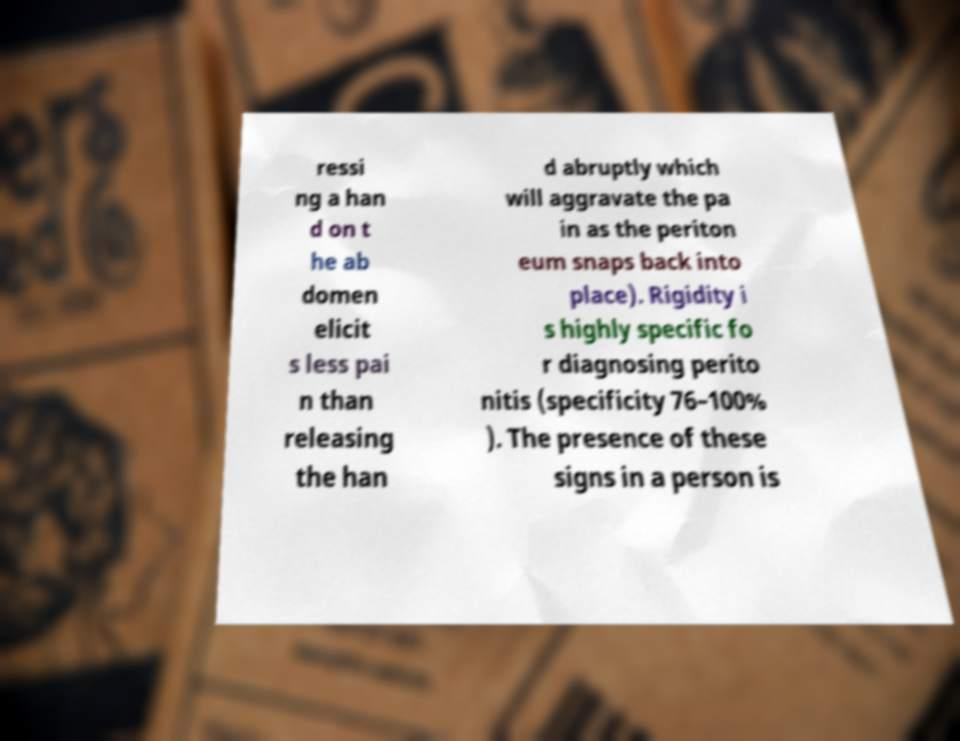There's text embedded in this image that I need extracted. Can you transcribe it verbatim? ressi ng a han d on t he ab domen elicit s less pai n than releasing the han d abruptly which will aggravate the pa in as the periton eum snaps back into place). Rigidity i s highly specific fo r diagnosing perito nitis (specificity 76–100% ). The presence of these signs in a person is 